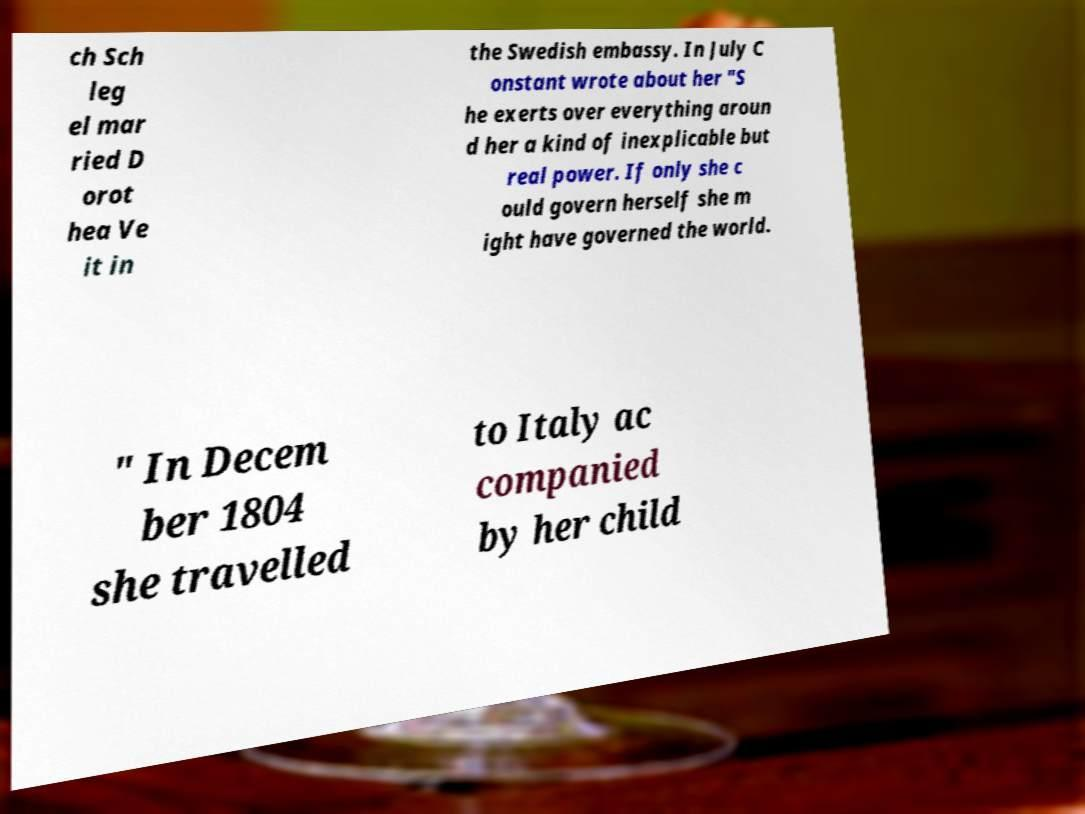For documentation purposes, I need the text within this image transcribed. Could you provide that? ch Sch leg el mar ried D orot hea Ve it in the Swedish embassy. In July C onstant wrote about her "S he exerts over everything aroun d her a kind of inexplicable but real power. If only she c ould govern herself she m ight have governed the world. " In Decem ber 1804 she travelled to Italy ac companied by her child 